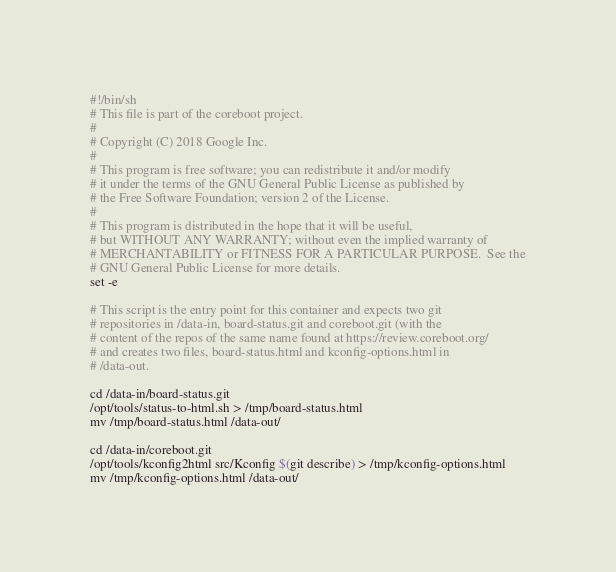Convert code to text. <code><loc_0><loc_0><loc_500><loc_500><_Bash_>#!/bin/sh
# This file is part of the coreboot project.
#
# Copyright (C) 2018 Google Inc.
#
# This program is free software; you can redistribute it and/or modify
# it under the terms of the GNU General Public License as published by
# the Free Software Foundation; version 2 of the License.
#
# This program is distributed in the hope that it will be useful,
# but WITHOUT ANY WARRANTY; without even the implied warranty of
# MERCHANTABILITY or FITNESS FOR A PARTICULAR PURPOSE.  See the
# GNU General Public License for more details.
set -e

# This script is the entry point for this container and expects two git
# repositories in /data-in, board-status.git and coreboot.git (with the
# content of the repos of the same name found at https://review.coreboot.org/
# and creates two files, board-status.html and kconfig-options.html in
# /data-out.

cd /data-in/board-status.git
/opt/tools/status-to-html.sh > /tmp/board-status.html
mv /tmp/board-status.html /data-out/

cd /data-in/coreboot.git
/opt/tools/kconfig2html src/Kconfig $(git describe) > /tmp/kconfig-options.html
mv /tmp/kconfig-options.html /data-out/
</code> 